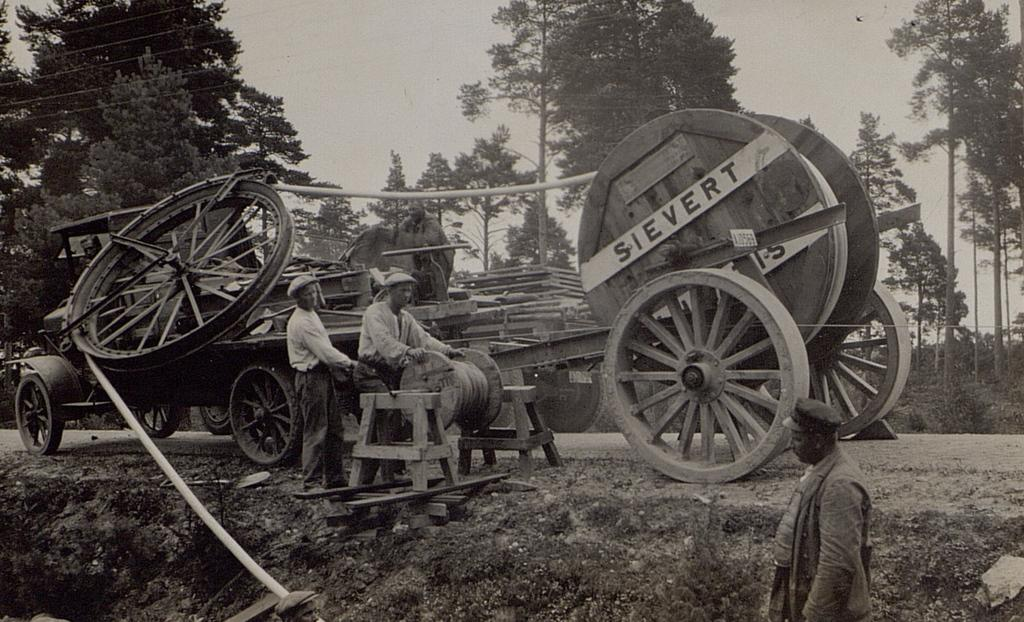What type of image is being described? The image is an old black and white picture. What can be seen in the foreground of the image? There are three people on a path in the image. What is located behind the people in the image? There appears to be a vehicle behind the people. What type of natural scenery is visible in the background of the image? Trees are visible in the background of the image. What else can be seen in the background of the image? The sky is visible in the background of the image. What type of quiver can be seen in the hands of the people in the image? There is no quiver present in the image; the people are not holding any such object. What rhythm is being followed by the people in the image? There is no indication of a rhythm or any musical activity in the image. 